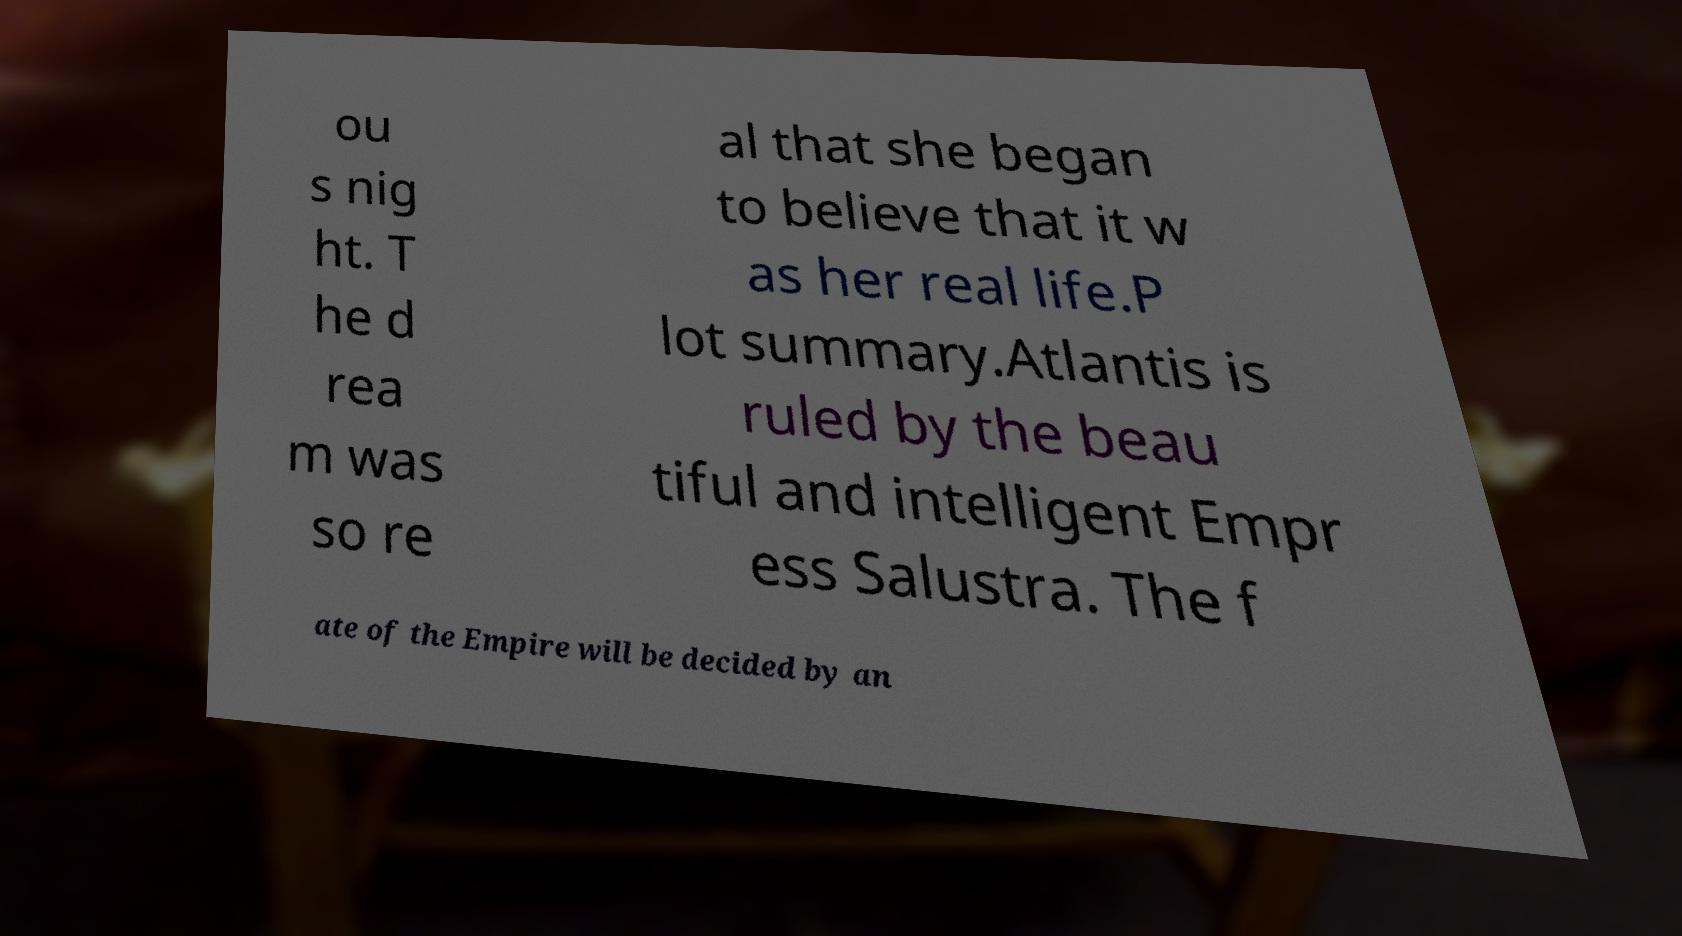I need the written content from this picture converted into text. Can you do that? ou s nig ht. T he d rea m was so re al that she began to believe that it w as her real life.P lot summary.Atlantis is ruled by the beau tiful and intelligent Empr ess Salustra. The f ate of the Empire will be decided by an 